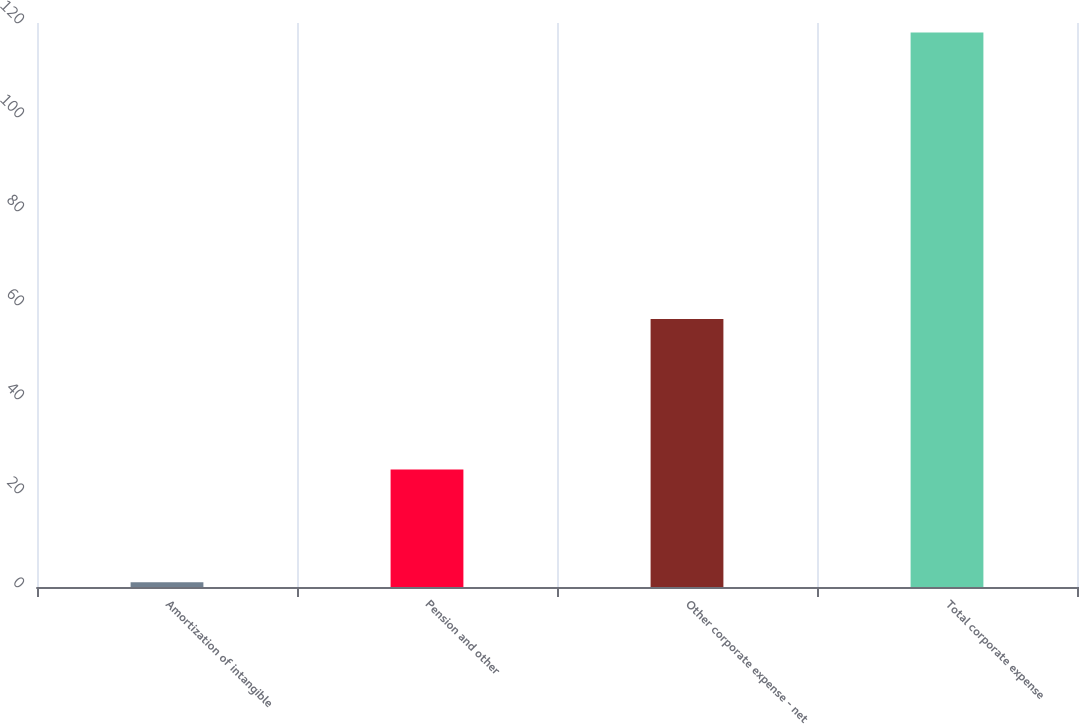Convert chart. <chart><loc_0><loc_0><loc_500><loc_500><bar_chart><fcel>Amortization of intangible<fcel>Pension and other<fcel>Other corporate expense - net<fcel>Total corporate expense<nl><fcel>1<fcel>25<fcel>57<fcel>118<nl></chart> 